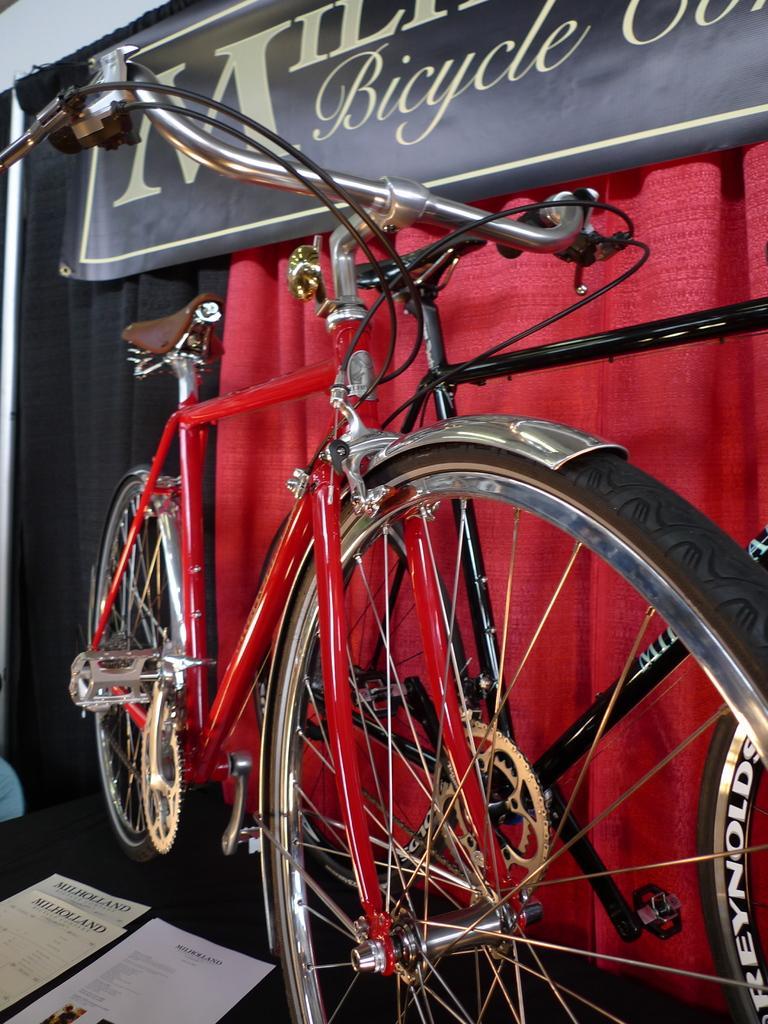How would you summarize this image in a sentence or two? This is a zoomed in picture. On the left there is a table on the top of which papers are placed and we can see a red color bicycle is placed on the top of the table. In the background there is a red color curtain and we can see a black color curtain and black color board on which we can see the text. 